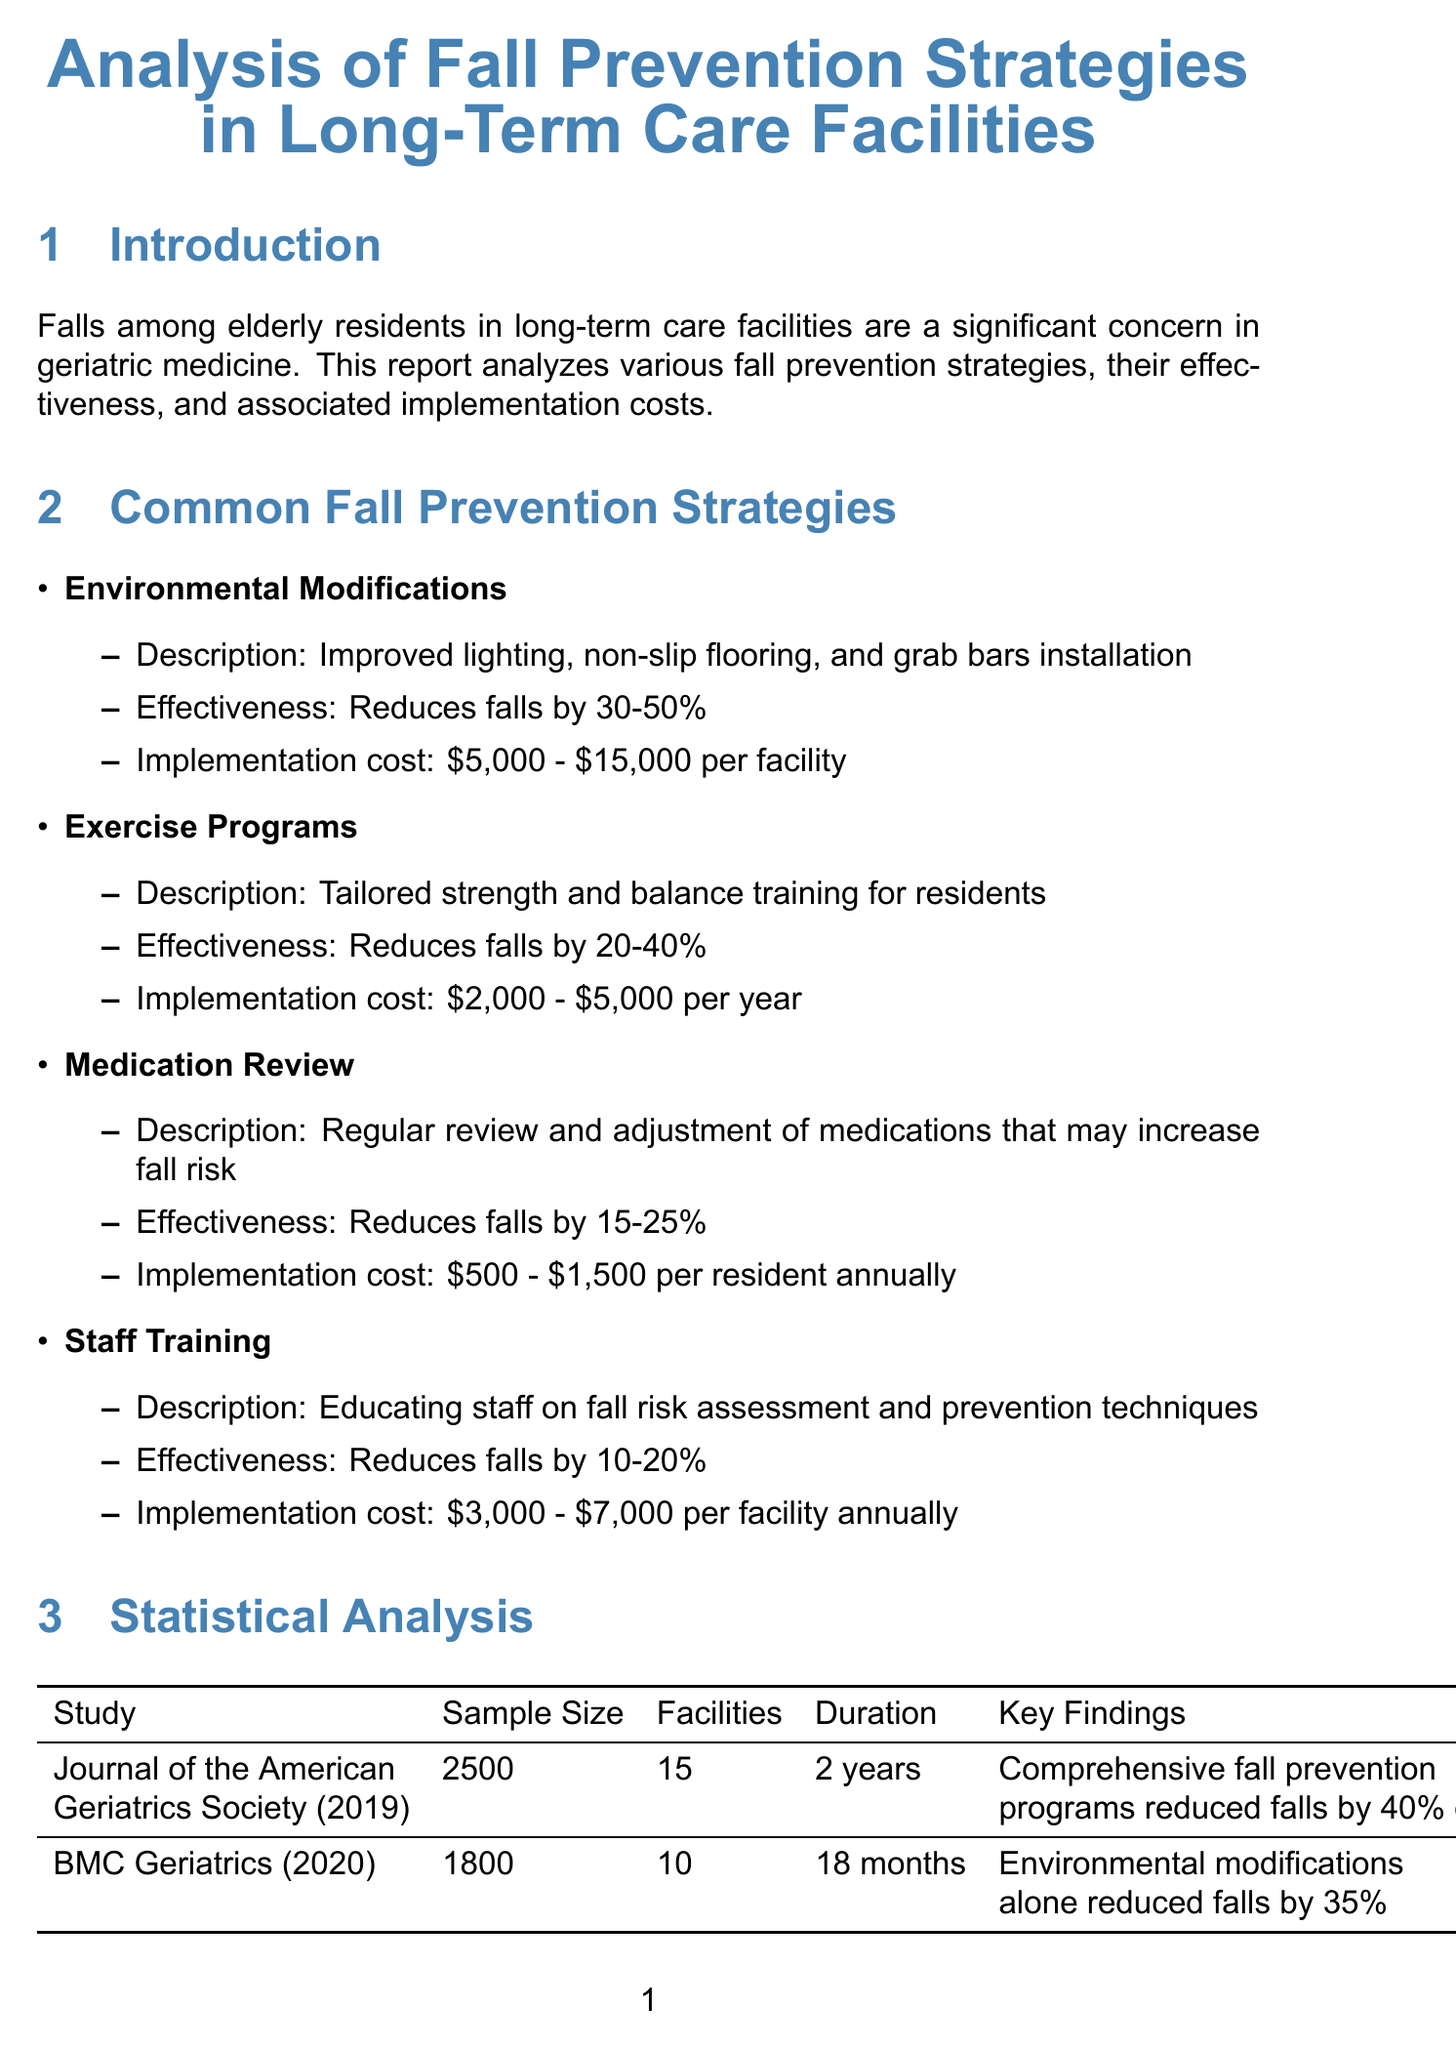What are the three implemented strategies at Sunrise Senior Living, Boston? The document lists the strategies that were implemented at this facility, which are Environmental Modifications, Exercise Programs, and Staff Training.
Answer: Environmental Modifications, Exercise Programs, Staff Training What is the effectiveness range of exercise programs in reducing falls? The effectiveness of exercise programs as stated in the document shows a range of reduction in falls, which is between 20 to 40 percent.
Answer: 20-40% What was the sample size of the study published in the Journal of the American Geriatrics Society (2019)? The report provides specific details about the study, including the sample size which is a key point of statistical analysis.
Answer: 2500 How much can implementing environmental modifications cost per facility? The document details the implementation cost for environmental modifications, which is essential for planning budgets in care facilities.
Answer: $5,000 - $15,000 What is the percentage reduction of falls from comprehensive fall prevention programs? The findings indicate a specific percentage reduction of falls due to comprehensive fall prevention programs in the statistical analysis section.
Answer: 40% What is the estimated cost-saving for Sunrise Senior Living annually due to fall prevention strategies? The document provides specific results from the case study including financial outcomes, particularly the annual cost savings.
Answer: $120,000 What percentage increase in resident satisfaction was reported at Sunrise Senior Living? The report includes specific outcomes from the case study that highlight improvements in resident satisfaction.
Answer: 30% Which organization found that for every £1 spent on fall prevention, £2.50 was saved in healthcare costs? This information gives insight into the broader impact of fall prevention strategies on healthcare expenses, which is mentioned in the cost-effectiveness analysis.
Answer: National Institute for Health and Care Excellence (NICE) What kind of training is recommended for staff in the fall prevention strategies? The report emphasizes the importance of staff training, with specific focus on the type of training essential for effective fall prevention.
Answer: Fall risk assessment and prevention techniques 